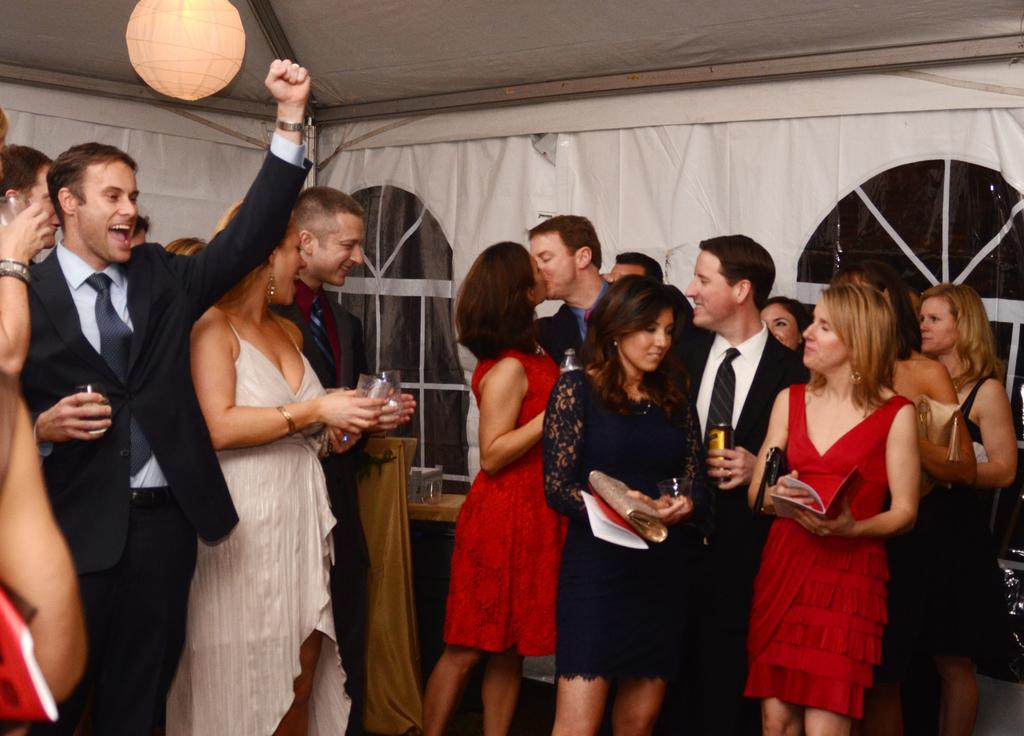What is happening in the image involving the group of people? The group of men and women is enjoying a party. Where are the people located in the image? They are standing in the front. What can be seen in the background of the image? There is a canopy tent and a hanging light in the background. What type of milk is being served at the party in the image? There is no milk visible in the image, and it is not mentioned that any milk is being served at the party. 